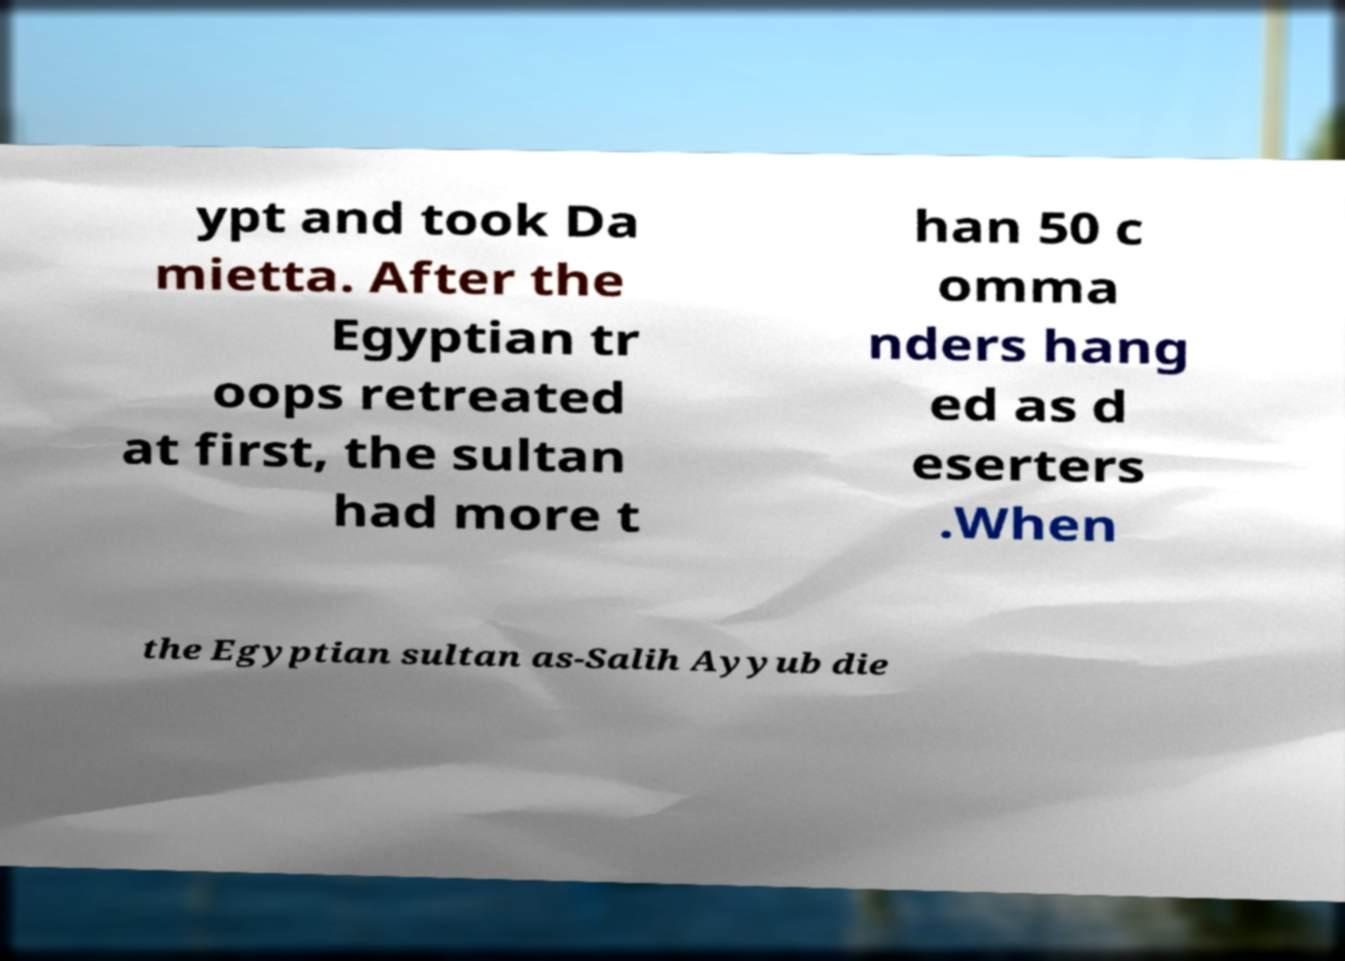Could you assist in decoding the text presented in this image and type it out clearly? ypt and took Da mietta. After the Egyptian tr oops retreated at first, the sultan had more t han 50 c omma nders hang ed as d eserters .When the Egyptian sultan as-Salih Ayyub die 